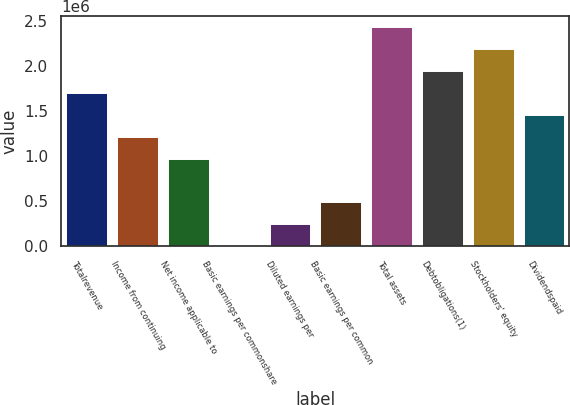<chart> <loc_0><loc_0><loc_500><loc_500><bar_chart><fcel>Totalrevenue<fcel>Income from continuing<fcel>Net income applicable to<fcel>Basic earnings per commonshare<fcel>Diluted earnings per<fcel>Basic earnings per common<fcel>Total assets<fcel>Debtobligations(1)<fcel>Stockholders' equity<fcel>Dividendspaid<nl><fcel>1.70181e+06<fcel>1.21558e+06<fcel>972462<fcel>0.76<fcel>243116<fcel>486231<fcel>2.43115e+06<fcel>1.94492e+06<fcel>2.18804e+06<fcel>1.45869e+06<nl></chart> 